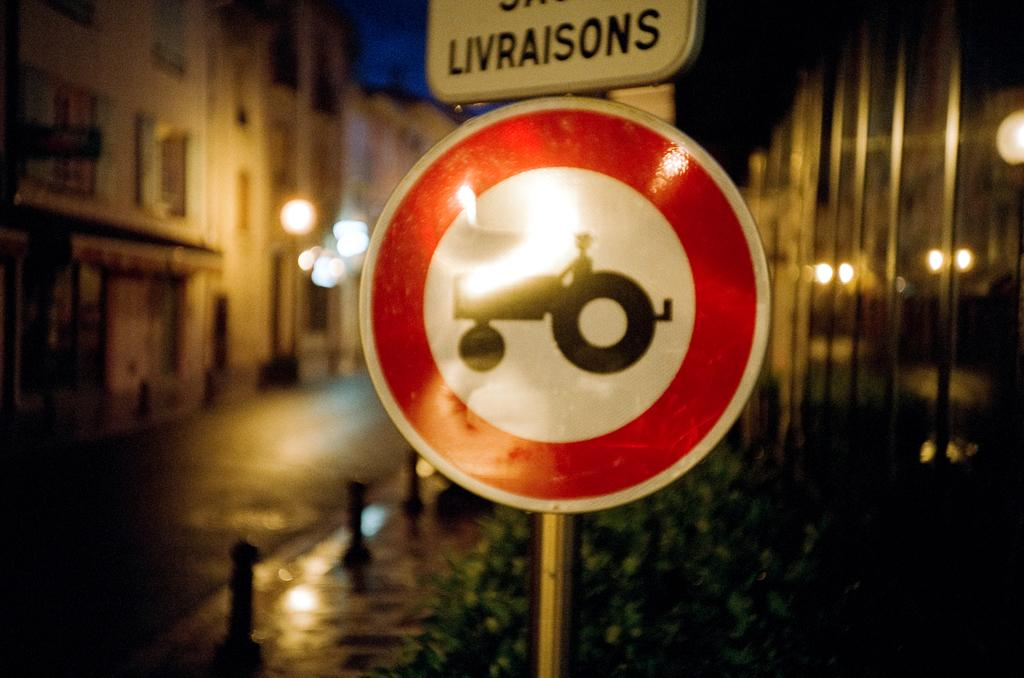<image>
Provide a brief description of the given image. A round red and white sign has a tractor on it and a sign above it that says Livraisons. 